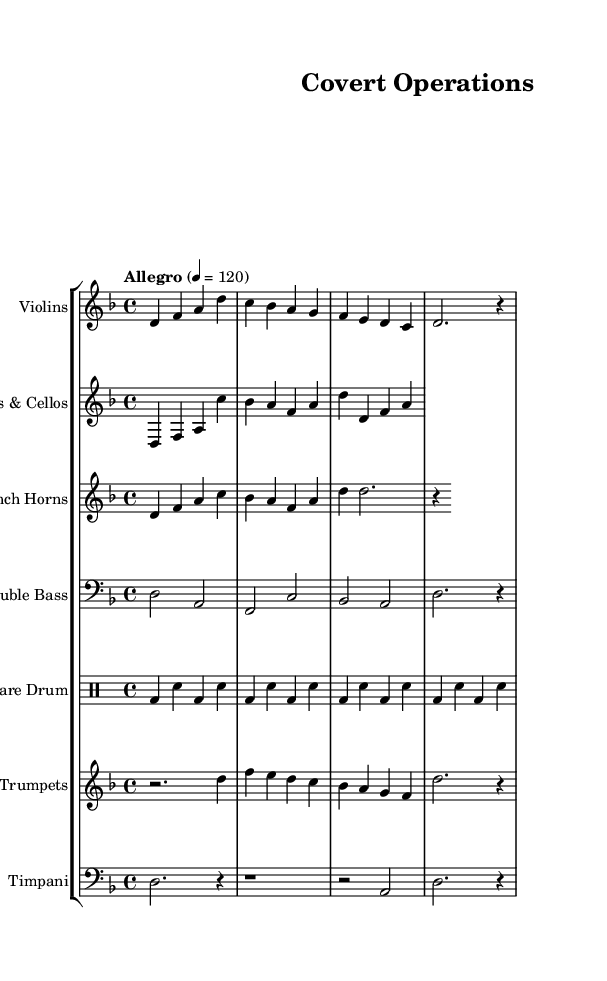What is the key signature of this music? The key signature is indicated at the beginning of the staff, showing two flats (B♭ and E♭). This is the key signature for D minor.
Answer: D minor What is the time signature of the score? The time signature appears at the beginning of the staff, where it is represented by "4/4", showing that there are four beats in a measure and the quarter note gets one beat.
Answer: 4/4 What is the tempo marking given for this piece? The tempo marking appears at the start and states "Allegro" with a metronome marking of 120, indicating a brisk pace for the music.
Answer: Allegro, 120 How many measures are in the Violins' part? To find the number of measures, one can count the individual measures marked in the Violins' part. There are a total of four measures.
Answer: 4 Which instrument plays the bass line? By examining the score, the Double Bass part is indicated with the clef "bass," denoting it plays the lower-range notes and the bass line.
Answer: Double Bass What rhythmic pattern is used by the Snare Drum? The rhythmic notation consists of alternating bass and snare notes, appearing consistently in a 'bass-snare' pattern every measure.
Answer: Bass-snare In which section does the Trumpet play its resting note? The Trumpet part has a rest at the beginning, indicated by "r" followed by a "2", indicating a half measure of silence before continuing.
Answer: Beginning 